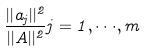Convert formula to latex. <formula><loc_0><loc_0><loc_500><loc_500>\frac { | | a _ { j } | | ^ { 2 } } { | | A | | ^ { 2 } } j = 1 , \cdot \cdot \cdot , m</formula> 